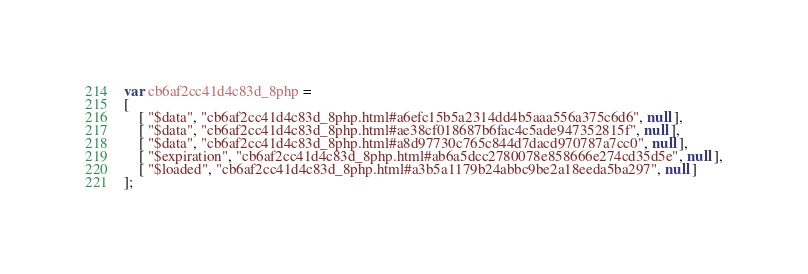<code> <loc_0><loc_0><loc_500><loc_500><_JavaScript_>var cb6af2cc41d4c83d_8php =
[
    [ "$data", "cb6af2cc41d4c83d_8php.html#a6efc15b5a2314dd4b5aaa556a375c6d6", null ],
    [ "$data", "cb6af2cc41d4c83d_8php.html#ae38cf018687b6fac4c5ade947352815f", null ],
    [ "$data", "cb6af2cc41d4c83d_8php.html#a8d97730c765c844d7dacd970787a7cc0", null ],
    [ "$expiration", "cb6af2cc41d4c83d_8php.html#ab6a5dcc2780078e858666e274cd35d5e", null ],
    [ "$loaded", "cb6af2cc41d4c83d_8php.html#a3b5a1179b24abbc9be2a18eeda5ba297", null ]
];</code> 